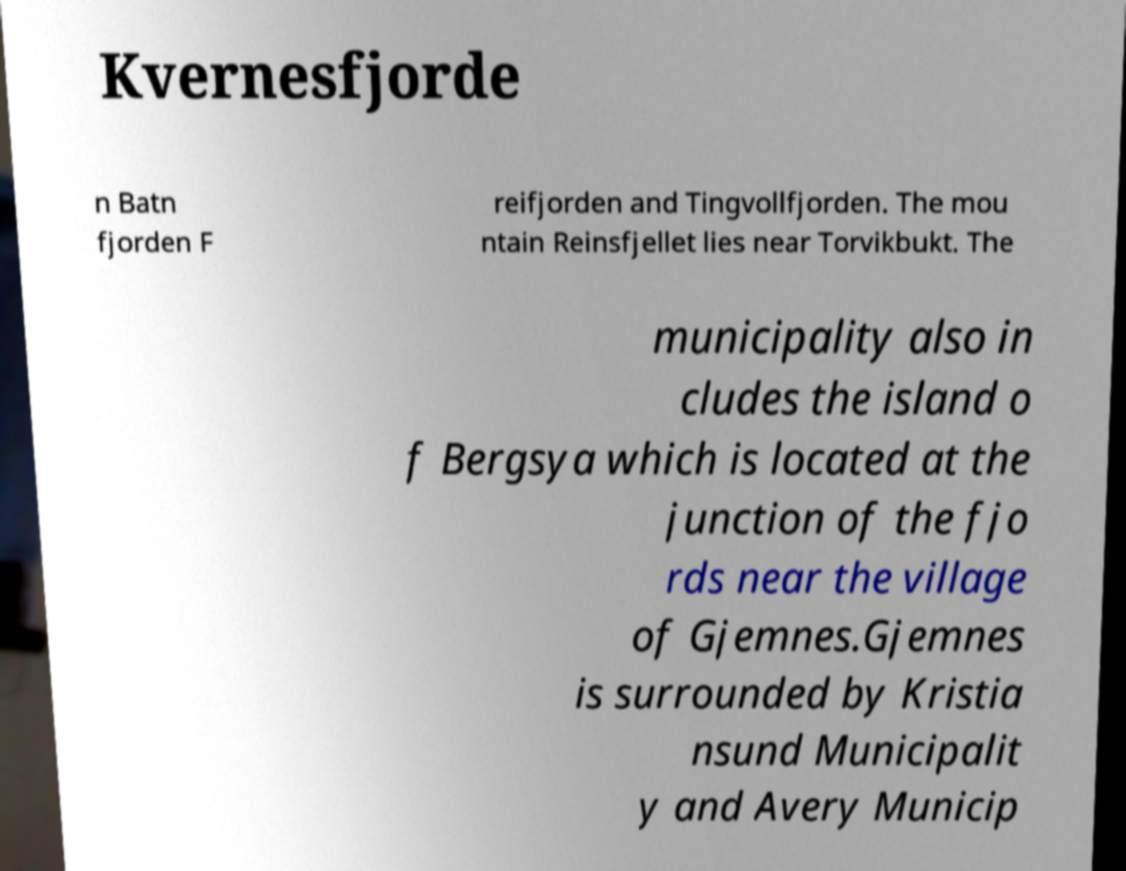There's text embedded in this image that I need extracted. Can you transcribe it verbatim? Kvernesfjorde n Batn fjorden F reifjorden and Tingvollfjorden. The mou ntain Reinsfjellet lies near Torvikbukt. The municipality also in cludes the island o f Bergsya which is located at the junction of the fjo rds near the village of Gjemnes.Gjemnes is surrounded by Kristia nsund Municipalit y and Avery Municip 